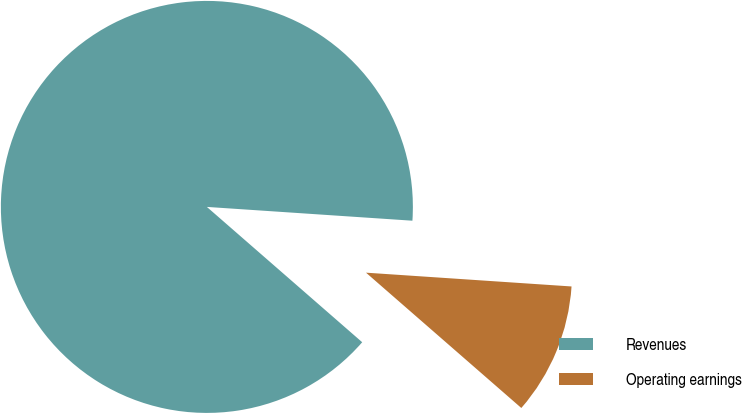Convert chart. <chart><loc_0><loc_0><loc_500><loc_500><pie_chart><fcel>Revenues<fcel>Operating earnings<nl><fcel>89.66%<fcel>10.34%<nl></chart> 